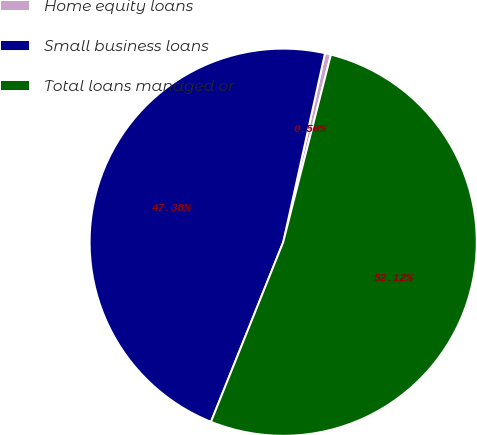Convert chart to OTSL. <chart><loc_0><loc_0><loc_500><loc_500><pie_chart><fcel>Home equity loans<fcel>Small business loans<fcel>Total loans managed or<nl><fcel>0.5%<fcel>47.38%<fcel>52.12%<nl></chart> 